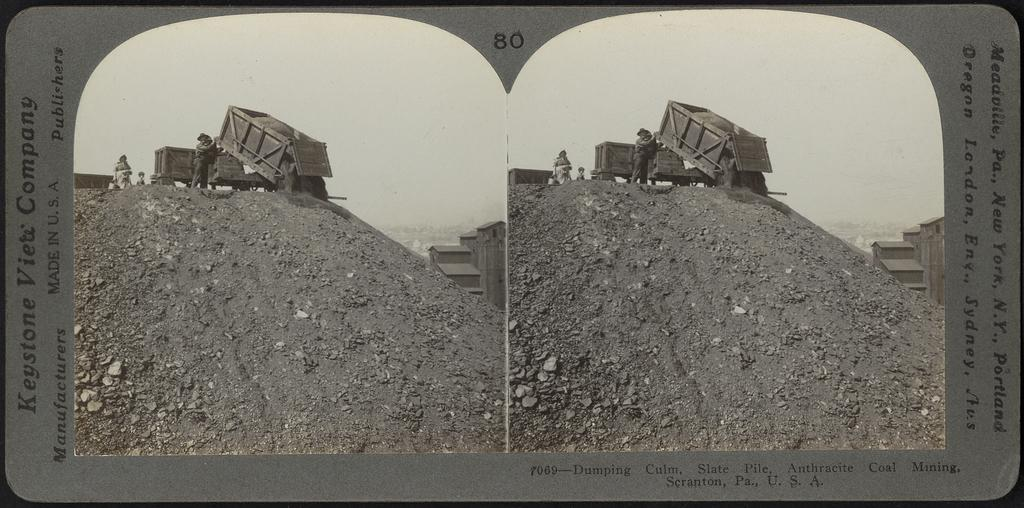<image>
Offer a succinct explanation of the picture presented. Keystone View Company type card that is # 80 and has a picture of a construction vehicle dumping waste. 